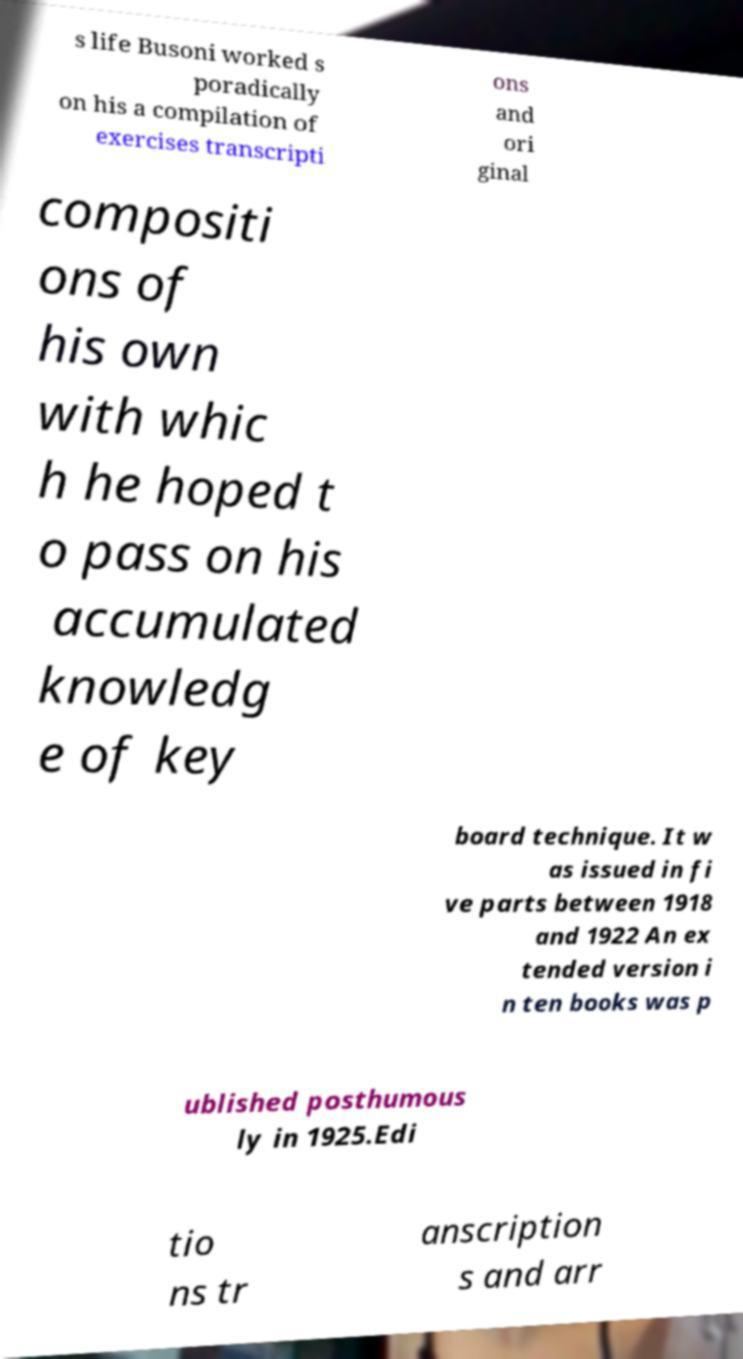Please identify and transcribe the text found in this image. s life Busoni worked s poradically on his a compilation of exercises transcripti ons and ori ginal compositi ons of his own with whic h he hoped t o pass on his accumulated knowledg e of key board technique. It w as issued in fi ve parts between 1918 and 1922 An ex tended version i n ten books was p ublished posthumous ly in 1925.Edi tio ns tr anscription s and arr 